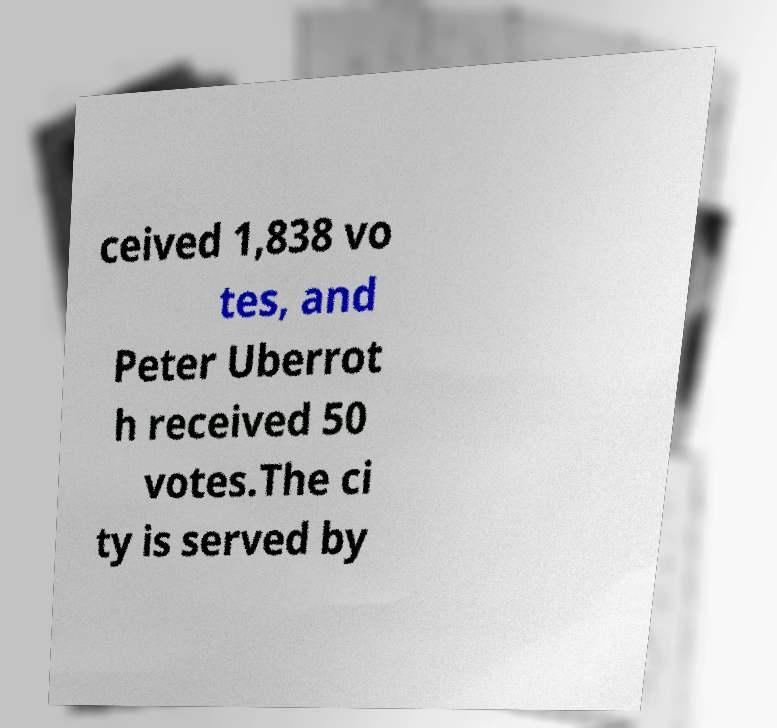For documentation purposes, I need the text within this image transcribed. Could you provide that? ceived 1,838 vo tes, and Peter Uberrot h received 50 votes.The ci ty is served by 